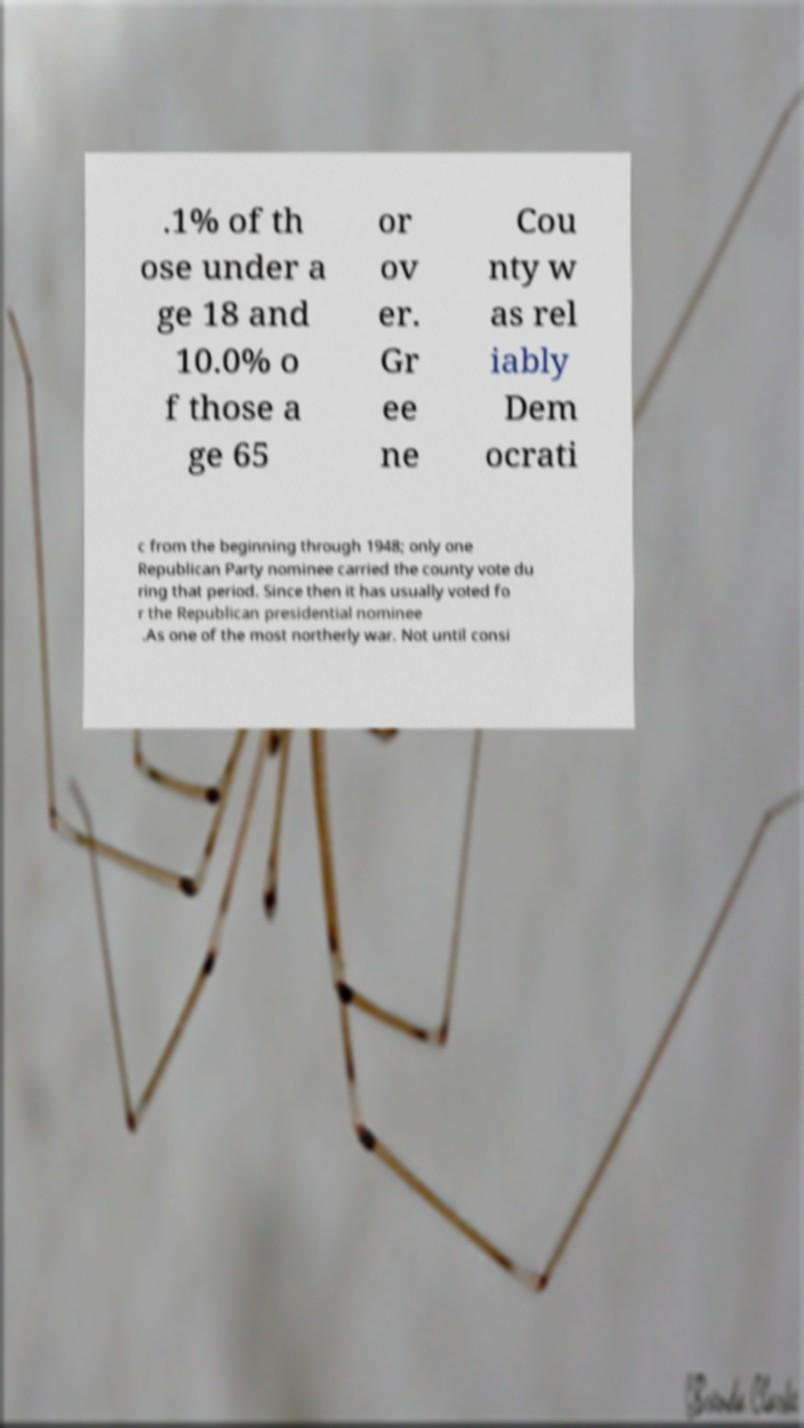I need the written content from this picture converted into text. Can you do that? .1% of th ose under a ge 18 and 10.0% o f those a ge 65 or ov er. Gr ee ne Cou nty w as rel iably Dem ocrati c from the beginning through 1948; only one Republican Party nominee carried the county vote du ring that period. Since then it has usually voted fo r the Republican presidential nominee .As one of the most northerly war. Not until consi 